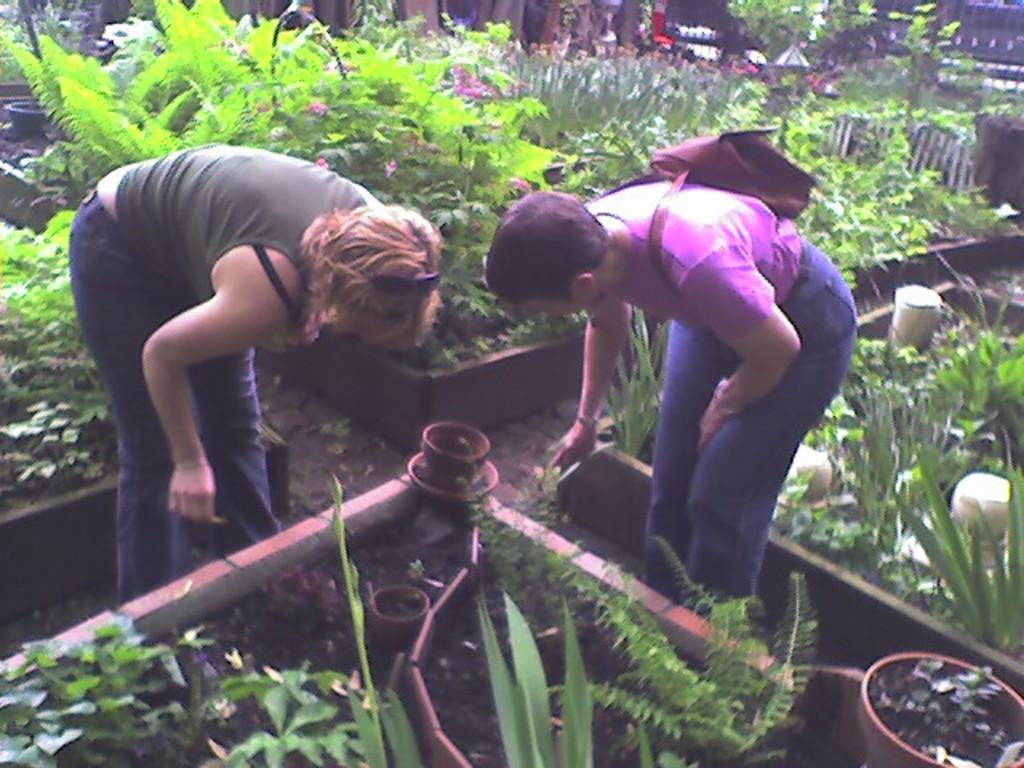Could you give a brief overview of what you see in this image? In this image in the foreground there are two people, one person holding a backpack they both are bending, in the middle there are few flower pots, on which there are plants visible. 